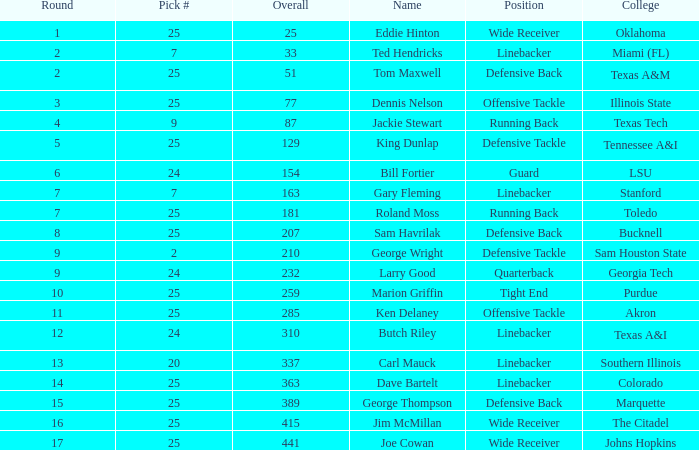What term is used for choosing 25 out of a total of 207? Sam Havrilak. 